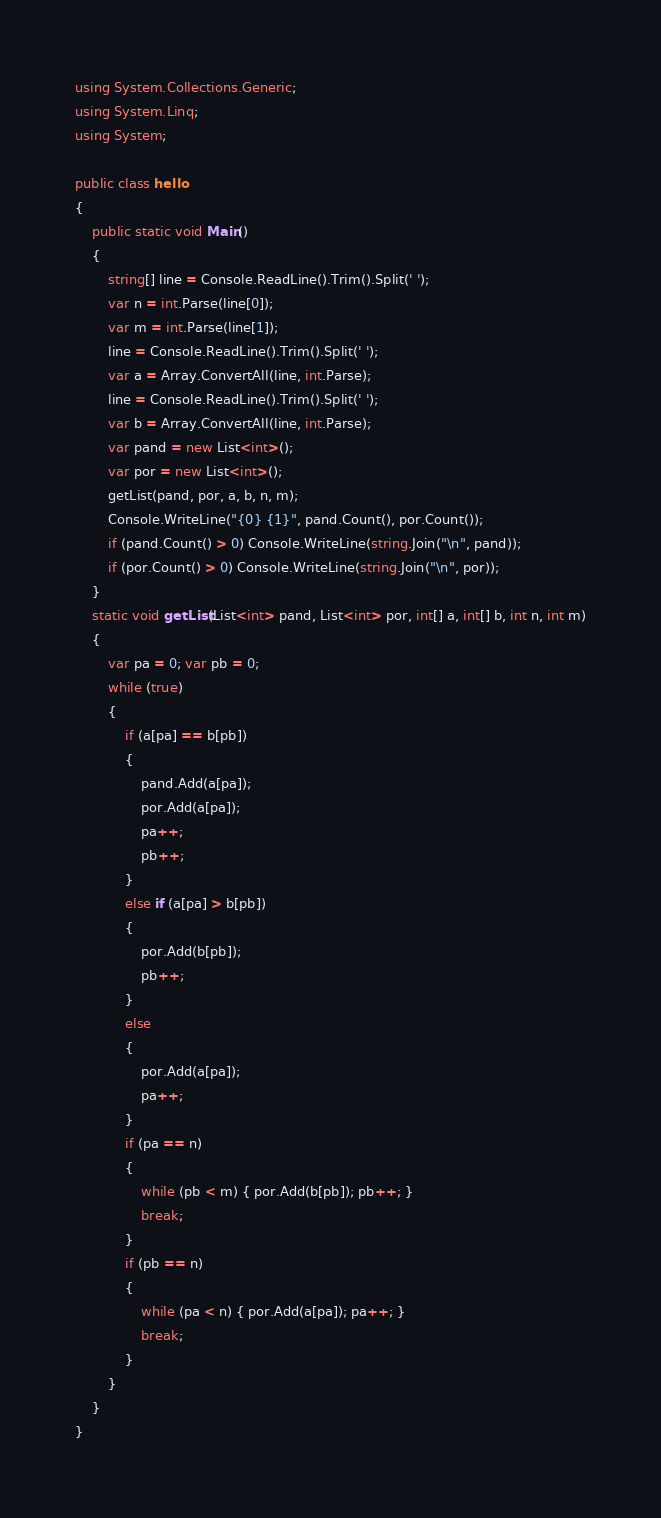Convert code to text. <code><loc_0><loc_0><loc_500><loc_500><_C#_>using System.Collections.Generic;
using System.Linq;
using System;

public class hello
{
	public static void Main()
	{
		string[] line = Console.ReadLine().Trim().Split(' ');
		var n = int.Parse(line[0]);
		var m = int.Parse(line[1]);
		line = Console.ReadLine().Trim().Split(' ');
		var a = Array.ConvertAll(line, int.Parse);
		line = Console.ReadLine().Trim().Split(' ');
		var b = Array.ConvertAll(line, int.Parse);
		var pand = new List<int>();
		var por = new List<int>();
		getList(pand, por, a, b, n, m);
		Console.WriteLine("{0} {1}", pand.Count(), por.Count());
		if (pand.Count() > 0) Console.WriteLine(string.Join("\n", pand));
		if (por.Count() > 0) Console.WriteLine(string.Join("\n", por));
	}
	static void getList(List<int> pand, List<int> por, int[] a, int[] b, int n, int m)
	{
		var pa = 0; var pb = 0;
		while (true)
		{
			if (a[pa] == b[pb])
			{
				pand.Add(a[pa]);
				por.Add(a[pa]);
				pa++;
				pb++;
			}
			else if (a[pa] > b[pb])
			{
				por.Add(b[pb]);
				pb++;
			}
			else
			{
				por.Add(a[pa]);
				pa++;
			}
			if (pa == n)
			{
				while (pb < m) { por.Add(b[pb]); pb++; }
				break;
			}
			if (pb == n)
			{
				while (pa < n) { por.Add(a[pa]); pa++; }
				break;
			}
		}
	}
}

</code> 